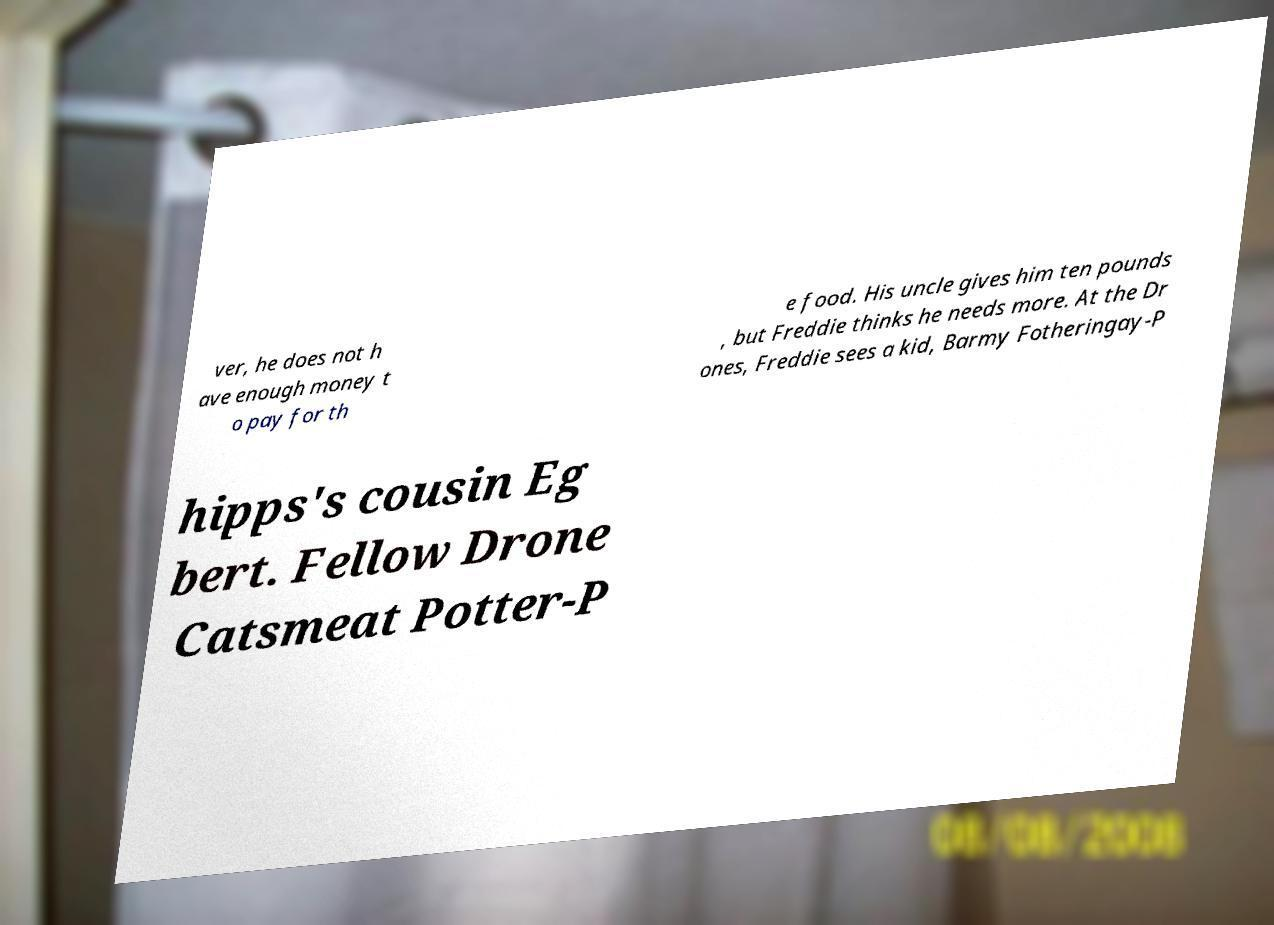Can you accurately transcribe the text from the provided image for me? ver, he does not h ave enough money t o pay for th e food. His uncle gives him ten pounds , but Freddie thinks he needs more. At the Dr ones, Freddie sees a kid, Barmy Fotheringay-P hipps's cousin Eg bert. Fellow Drone Catsmeat Potter-P 